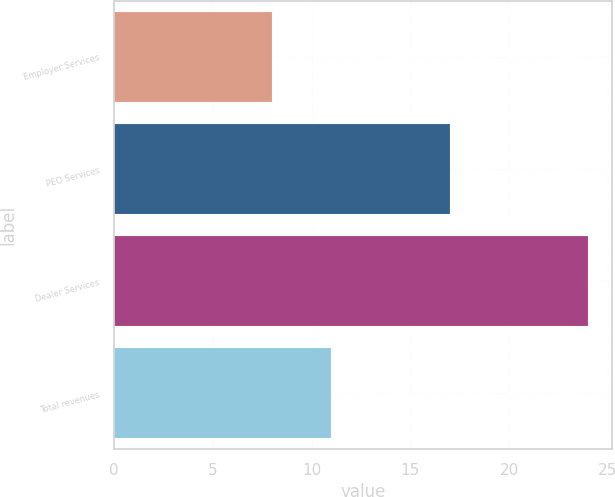<chart> <loc_0><loc_0><loc_500><loc_500><bar_chart><fcel>Employer Services<fcel>PEO Services<fcel>Dealer Services<fcel>Total revenues<nl><fcel>8<fcel>17<fcel>24<fcel>11<nl></chart> 